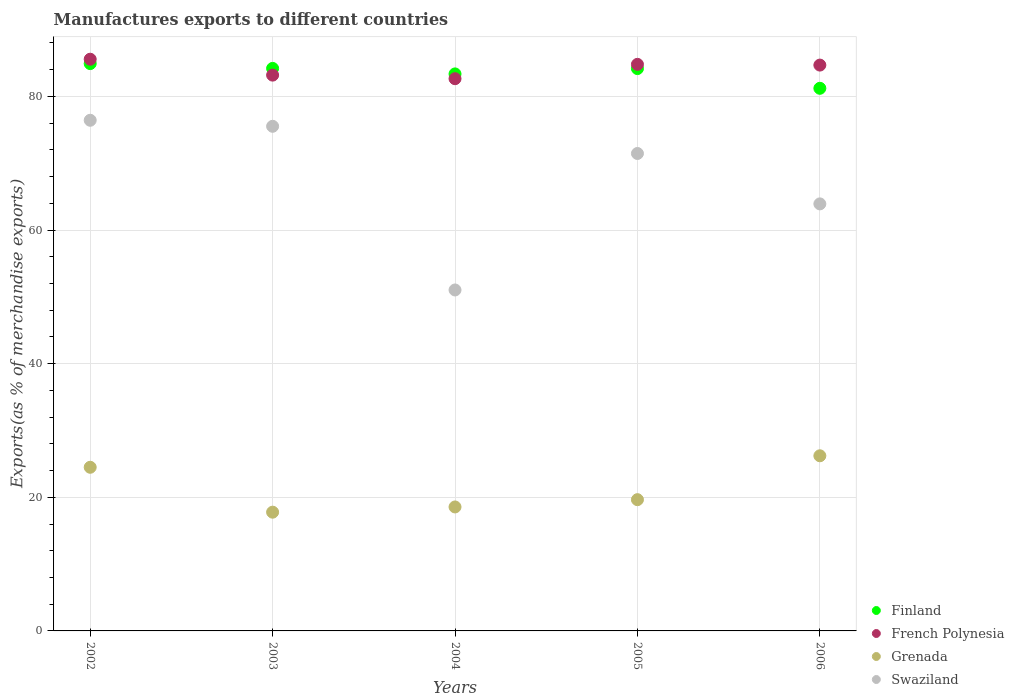Is the number of dotlines equal to the number of legend labels?
Your answer should be compact. Yes. What is the percentage of exports to different countries in Grenada in 2004?
Provide a succinct answer. 18.56. Across all years, what is the maximum percentage of exports to different countries in French Polynesia?
Your answer should be compact. 85.57. Across all years, what is the minimum percentage of exports to different countries in Grenada?
Your answer should be very brief. 17.77. In which year was the percentage of exports to different countries in Finland maximum?
Your response must be concise. 2002. What is the total percentage of exports to different countries in Swaziland in the graph?
Your response must be concise. 338.38. What is the difference between the percentage of exports to different countries in Swaziland in 2002 and that in 2005?
Keep it short and to the point. 4.97. What is the difference between the percentage of exports to different countries in French Polynesia in 2002 and the percentage of exports to different countries in Swaziland in 2005?
Your answer should be compact. 14.11. What is the average percentage of exports to different countries in Grenada per year?
Offer a terse response. 21.34. In the year 2006, what is the difference between the percentage of exports to different countries in Finland and percentage of exports to different countries in French Polynesia?
Ensure brevity in your answer.  -3.47. What is the ratio of the percentage of exports to different countries in French Polynesia in 2002 to that in 2006?
Your answer should be compact. 1.01. What is the difference between the highest and the second highest percentage of exports to different countries in Finland?
Ensure brevity in your answer.  0.72. What is the difference between the highest and the lowest percentage of exports to different countries in French Polynesia?
Make the answer very short. 2.92. In how many years, is the percentage of exports to different countries in Swaziland greater than the average percentage of exports to different countries in Swaziland taken over all years?
Your answer should be very brief. 3. Is it the case that in every year, the sum of the percentage of exports to different countries in French Polynesia and percentage of exports to different countries in Swaziland  is greater than the sum of percentage of exports to different countries in Grenada and percentage of exports to different countries in Finland?
Provide a succinct answer. No. Is it the case that in every year, the sum of the percentage of exports to different countries in Grenada and percentage of exports to different countries in Swaziland  is greater than the percentage of exports to different countries in Finland?
Your answer should be very brief. No. Does the percentage of exports to different countries in Swaziland monotonically increase over the years?
Ensure brevity in your answer.  No. How many years are there in the graph?
Provide a succinct answer. 5. What is the difference between two consecutive major ticks on the Y-axis?
Your answer should be very brief. 20. How many legend labels are there?
Offer a very short reply. 4. How are the legend labels stacked?
Provide a succinct answer. Vertical. What is the title of the graph?
Your answer should be compact. Manufactures exports to different countries. What is the label or title of the Y-axis?
Offer a very short reply. Exports(as % of merchandise exports). What is the Exports(as % of merchandise exports) in Finland in 2002?
Provide a succinct answer. 84.92. What is the Exports(as % of merchandise exports) of French Polynesia in 2002?
Provide a short and direct response. 85.57. What is the Exports(as % of merchandise exports) in Grenada in 2002?
Offer a very short reply. 24.49. What is the Exports(as % of merchandise exports) in Swaziland in 2002?
Your response must be concise. 76.43. What is the Exports(as % of merchandise exports) of Finland in 2003?
Offer a very short reply. 84.2. What is the Exports(as % of merchandise exports) in French Polynesia in 2003?
Your answer should be compact. 83.19. What is the Exports(as % of merchandise exports) of Grenada in 2003?
Your answer should be very brief. 17.77. What is the Exports(as % of merchandise exports) of Swaziland in 2003?
Offer a terse response. 75.53. What is the Exports(as % of merchandise exports) of Finland in 2004?
Provide a short and direct response. 83.37. What is the Exports(as % of merchandise exports) of French Polynesia in 2004?
Offer a very short reply. 82.66. What is the Exports(as % of merchandise exports) of Grenada in 2004?
Make the answer very short. 18.56. What is the Exports(as % of merchandise exports) in Swaziland in 2004?
Provide a short and direct response. 51.03. What is the Exports(as % of merchandise exports) of Finland in 2005?
Provide a succinct answer. 84.17. What is the Exports(as % of merchandise exports) in French Polynesia in 2005?
Keep it short and to the point. 84.8. What is the Exports(as % of merchandise exports) in Grenada in 2005?
Ensure brevity in your answer.  19.65. What is the Exports(as % of merchandise exports) in Swaziland in 2005?
Make the answer very short. 71.46. What is the Exports(as % of merchandise exports) of Finland in 2006?
Ensure brevity in your answer.  81.22. What is the Exports(as % of merchandise exports) in French Polynesia in 2006?
Your answer should be very brief. 84.69. What is the Exports(as % of merchandise exports) in Grenada in 2006?
Keep it short and to the point. 26.21. What is the Exports(as % of merchandise exports) in Swaziland in 2006?
Provide a succinct answer. 63.92. Across all years, what is the maximum Exports(as % of merchandise exports) of Finland?
Offer a terse response. 84.92. Across all years, what is the maximum Exports(as % of merchandise exports) in French Polynesia?
Offer a terse response. 85.57. Across all years, what is the maximum Exports(as % of merchandise exports) in Grenada?
Ensure brevity in your answer.  26.21. Across all years, what is the maximum Exports(as % of merchandise exports) of Swaziland?
Offer a very short reply. 76.43. Across all years, what is the minimum Exports(as % of merchandise exports) of Finland?
Keep it short and to the point. 81.22. Across all years, what is the minimum Exports(as % of merchandise exports) of French Polynesia?
Your response must be concise. 82.66. Across all years, what is the minimum Exports(as % of merchandise exports) in Grenada?
Provide a succinct answer. 17.77. Across all years, what is the minimum Exports(as % of merchandise exports) in Swaziland?
Your answer should be very brief. 51.03. What is the total Exports(as % of merchandise exports) in Finland in the graph?
Your answer should be very brief. 417.87. What is the total Exports(as % of merchandise exports) in French Polynesia in the graph?
Ensure brevity in your answer.  420.91. What is the total Exports(as % of merchandise exports) in Grenada in the graph?
Make the answer very short. 106.68. What is the total Exports(as % of merchandise exports) in Swaziland in the graph?
Keep it short and to the point. 338.38. What is the difference between the Exports(as % of merchandise exports) in Finland in 2002 and that in 2003?
Offer a terse response. 0.72. What is the difference between the Exports(as % of merchandise exports) in French Polynesia in 2002 and that in 2003?
Make the answer very short. 2.38. What is the difference between the Exports(as % of merchandise exports) in Grenada in 2002 and that in 2003?
Ensure brevity in your answer.  6.72. What is the difference between the Exports(as % of merchandise exports) of Swaziland in 2002 and that in 2003?
Your response must be concise. 0.9. What is the difference between the Exports(as % of merchandise exports) of Finland in 2002 and that in 2004?
Offer a terse response. 1.54. What is the difference between the Exports(as % of merchandise exports) in French Polynesia in 2002 and that in 2004?
Ensure brevity in your answer.  2.92. What is the difference between the Exports(as % of merchandise exports) in Grenada in 2002 and that in 2004?
Offer a very short reply. 5.94. What is the difference between the Exports(as % of merchandise exports) of Swaziland in 2002 and that in 2004?
Provide a short and direct response. 25.4. What is the difference between the Exports(as % of merchandise exports) in Finland in 2002 and that in 2005?
Your response must be concise. 0.75. What is the difference between the Exports(as % of merchandise exports) of French Polynesia in 2002 and that in 2005?
Provide a succinct answer. 0.77. What is the difference between the Exports(as % of merchandise exports) of Grenada in 2002 and that in 2005?
Offer a terse response. 4.85. What is the difference between the Exports(as % of merchandise exports) in Swaziland in 2002 and that in 2005?
Give a very brief answer. 4.97. What is the difference between the Exports(as % of merchandise exports) of Finland in 2002 and that in 2006?
Provide a short and direct response. 3.7. What is the difference between the Exports(as % of merchandise exports) in French Polynesia in 2002 and that in 2006?
Provide a succinct answer. 0.88. What is the difference between the Exports(as % of merchandise exports) in Grenada in 2002 and that in 2006?
Provide a short and direct response. -1.72. What is the difference between the Exports(as % of merchandise exports) of Swaziland in 2002 and that in 2006?
Provide a succinct answer. 12.52. What is the difference between the Exports(as % of merchandise exports) in Finland in 2003 and that in 2004?
Provide a short and direct response. 0.82. What is the difference between the Exports(as % of merchandise exports) in French Polynesia in 2003 and that in 2004?
Provide a succinct answer. 0.54. What is the difference between the Exports(as % of merchandise exports) of Grenada in 2003 and that in 2004?
Provide a succinct answer. -0.78. What is the difference between the Exports(as % of merchandise exports) in Swaziland in 2003 and that in 2004?
Give a very brief answer. 24.5. What is the difference between the Exports(as % of merchandise exports) of Finland in 2003 and that in 2005?
Offer a terse response. 0.03. What is the difference between the Exports(as % of merchandise exports) in French Polynesia in 2003 and that in 2005?
Your answer should be compact. -1.61. What is the difference between the Exports(as % of merchandise exports) of Grenada in 2003 and that in 2005?
Your answer should be very brief. -1.87. What is the difference between the Exports(as % of merchandise exports) in Swaziland in 2003 and that in 2005?
Offer a very short reply. 4.07. What is the difference between the Exports(as % of merchandise exports) of Finland in 2003 and that in 2006?
Offer a very short reply. 2.98. What is the difference between the Exports(as % of merchandise exports) of French Polynesia in 2003 and that in 2006?
Provide a succinct answer. -1.5. What is the difference between the Exports(as % of merchandise exports) of Grenada in 2003 and that in 2006?
Your answer should be compact. -8.44. What is the difference between the Exports(as % of merchandise exports) of Swaziland in 2003 and that in 2006?
Provide a succinct answer. 11.61. What is the difference between the Exports(as % of merchandise exports) of Finland in 2004 and that in 2005?
Your answer should be compact. -0.8. What is the difference between the Exports(as % of merchandise exports) of French Polynesia in 2004 and that in 2005?
Offer a terse response. -2.15. What is the difference between the Exports(as % of merchandise exports) in Grenada in 2004 and that in 2005?
Provide a short and direct response. -1.09. What is the difference between the Exports(as % of merchandise exports) in Swaziland in 2004 and that in 2005?
Make the answer very short. -20.43. What is the difference between the Exports(as % of merchandise exports) in Finland in 2004 and that in 2006?
Make the answer very short. 2.15. What is the difference between the Exports(as % of merchandise exports) in French Polynesia in 2004 and that in 2006?
Ensure brevity in your answer.  -2.04. What is the difference between the Exports(as % of merchandise exports) in Grenada in 2004 and that in 2006?
Provide a succinct answer. -7.66. What is the difference between the Exports(as % of merchandise exports) in Swaziland in 2004 and that in 2006?
Offer a very short reply. -12.89. What is the difference between the Exports(as % of merchandise exports) in Finland in 2005 and that in 2006?
Offer a very short reply. 2.95. What is the difference between the Exports(as % of merchandise exports) of French Polynesia in 2005 and that in 2006?
Your answer should be very brief. 0.11. What is the difference between the Exports(as % of merchandise exports) in Grenada in 2005 and that in 2006?
Your answer should be very brief. -6.57. What is the difference between the Exports(as % of merchandise exports) of Swaziland in 2005 and that in 2006?
Keep it short and to the point. 7.54. What is the difference between the Exports(as % of merchandise exports) of Finland in 2002 and the Exports(as % of merchandise exports) of French Polynesia in 2003?
Give a very brief answer. 1.73. What is the difference between the Exports(as % of merchandise exports) in Finland in 2002 and the Exports(as % of merchandise exports) in Grenada in 2003?
Make the answer very short. 67.14. What is the difference between the Exports(as % of merchandise exports) in Finland in 2002 and the Exports(as % of merchandise exports) in Swaziland in 2003?
Keep it short and to the point. 9.38. What is the difference between the Exports(as % of merchandise exports) of French Polynesia in 2002 and the Exports(as % of merchandise exports) of Grenada in 2003?
Give a very brief answer. 67.8. What is the difference between the Exports(as % of merchandise exports) in French Polynesia in 2002 and the Exports(as % of merchandise exports) in Swaziland in 2003?
Give a very brief answer. 10.04. What is the difference between the Exports(as % of merchandise exports) in Grenada in 2002 and the Exports(as % of merchandise exports) in Swaziland in 2003?
Your answer should be compact. -51.04. What is the difference between the Exports(as % of merchandise exports) in Finland in 2002 and the Exports(as % of merchandise exports) in French Polynesia in 2004?
Ensure brevity in your answer.  2.26. What is the difference between the Exports(as % of merchandise exports) of Finland in 2002 and the Exports(as % of merchandise exports) of Grenada in 2004?
Make the answer very short. 66.36. What is the difference between the Exports(as % of merchandise exports) of Finland in 2002 and the Exports(as % of merchandise exports) of Swaziland in 2004?
Make the answer very short. 33.88. What is the difference between the Exports(as % of merchandise exports) in French Polynesia in 2002 and the Exports(as % of merchandise exports) in Grenada in 2004?
Your answer should be compact. 67.02. What is the difference between the Exports(as % of merchandise exports) of French Polynesia in 2002 and the Exports(as % of merchandise exports) of Swaziland in 2004?
Offer a terse response. 34.54. What is the difference between the Exports(as % of merchandise exports) of Grenada in 2002 and the Exports(as % of merchandise exports) of Swaziland in 2004?
Your answer should be very brief. -26.54. What is the difference between the Exports(as % of merchandise exports) of Finland in 2002 and the Exports(as % of merchandise exports) of French Polynesia in 2005?
Your answer should be very brief. 0.11. What is the difference between the Exports(as % of merchandise exports) of Finland in 2002 and the Exports(as % of merchandise exports) of Grenada in 2005?
Provide a short and direct response. 65.27. What is the difference between the Exports(as % of merchandise exports) in Finland in 2002 and the Exports(as % of merchandise exports) in Swaziland in 2005?
Make the answer very short. 13.45. What is the difference between the Exports(as % of merchandise exports) of French Polynesia in 2002 and the Exports(as % of merchandise exports) of Grenada in 2005?
Offer a terse response. 65.92. What is the difference between the Exports(as % of merchandise exports) of French Polynesia in 2002 and the Exports(as % of merchandise exports) of Swaziland in 2005?
Keep it short and to the point. 14.11. What is the difference between the Exports(as % of merchandise exports) in Grenada in 2002 and the Exports(as % of merchandise exports) in Swaziland in 2005?
Ensure brevity in your answer.  -46.97. What is the difference between the Exports(as % of merchandise exports) in Finland in 2002 and the Exports(as % of merchandise exports) in French Polynesia in 2006?
Provide a short and direct response. 0.22. What is the difference between the Exports(as % of merchandise exports) in Finland in 2002 and the Exports(as % of merchandise exports) in Grenada in 2006?
Your answer should be very brief. 58.7. What is the difference between the Exports(as % of merchandise exports) of Finland in 2002 and the Exports(as % of merchandise exports) of Swaziland in 2006?
Your answer should be compact. 21. What is the difference between the Exports(as % of merchandise exports) in French Polynesia in 2002 and the Exports(as % of merchandise exports) in Grenada in 2006?
Make the answer very short. 59.36. What is the difference between the Exports(as % of merchandise exports) of French Polynesia in 2002 and the Exports(as % of merchandise exports) of Swaziland in 2006?
Offer a terse response. 21.65. What is the difference between the Exports(as % of merchandise exports) in Grenada in 2002 and the Exports(as % of merchandise exports) in Swaziland in 2006?
Your answer should be very brief. -39.42. What is the difference between the Exports(as % of merchandise exports) of Finland in 2003 and the Exports(as % of merchandise exports) of French Polynesia in 2004?
Give a very brief answer. 1.54. What is the difference between the Exports(as % of merchandise exports) of Finland in 2003 and the Exports(as % of merchandise exports) of Grenada in 2004?
Your answer should be very brief. 65.64. What is the difference between the Exports(as % of merchandise exports) in Finland in 2003 and the Exports(as % of merchandise exports) in Swaziland in 2004?
Ensure brevity in your answer.  33.16. What is the difference between the Exports(as % of merchandise exports) in French Polynesia in 2003 and the Exports(as % of merchandise exports) in Grenada in 2004?
Your answer should be very brief. 64.64. What is the difference between the Exports(as % of merchandise exports) in French Polynesia in 2003 and the Exports(as % of merchandise exports) in Swaziland in 2004?
Give a very brief answer. 32.16. What is the difference between the Exports(as % of merchandise exports) of Grenada in 2003 and the Exports(as % of merchandise exports) of Swaziland in 2004?
Your response must be concise. -33.26. What is the difference between the Exports(as % of merchandise exports) of Finland in 2003 and the Exports(as % of merchandise exports) of French Polynesia in 2005?
Give a very brief answer. -0.61. What is the difference between the Exports(as % of merchandise exports) of Finland in 2003 and the Exports(as % of merchandise exports) of Grenada in 2005?
Your response must be concise. 64.55. What is the difference between the Exports(as % of merchandise exports) of Finland in 2003 and the Exports(as % of merchandise exports) of Swaziland in 2005?
Keep it short and to the point. 12.73. What is the difference between the Exports(as % of merchandise exports) in French Polynesia in 2003 and the Exports(as % of merchandise exports) in Grenada in 2005?
Offer a very short reply. 63.54. What is the difference between the Exports(as % of merchandise exports) in French Polynesia in 2003 and the Exports(as % of merchandise exports) in Swaziland in 2005?
Keep it short and to the point. 11.73. What is the difference between the Exports(as % of merchandise exports) of Grenada in 2003 and the Exports(as % of merchandise exports) of Swaziland in 2005?
Provide a short and direct response. -53.69. What is the difference between the Exports(as % of merchandise exports) in Finland in 2003 and the Exports(as % of merchandise exports) in French Polynesia in 2006?
Keep it short and to the point. -0.5. What is the difference between the Exports(as % of merchandise exports) in Finland in 2003 and the Exports(as % of merchandise exports) in Grenada in 2006?
Your answer should be very brief. 57.98. What is the difference between the Exports(as % of merchandise exports) in Finland in 2003 and the Exports(as % of merchandise exports) in Swaziland in 2006?
Offer a very short reply. 20.28. What is the difference between the Exports(as % of merchandise exports) of French Polynesia in 2003 and the Exports(as % of merchandise exports) of Grenada in 2006?
Give a very brief answer. 56.98. What is the difference between the Exports(as % of merchandise exports) of French Polynesia in 2003 and the Exports(as % of merchandise exports) of Swaziland in 2006?
Your answer should be very brief. 19.27. What is the difference between the Exports(as % of merchandise exports) of Grenada in 2003 and the Exports(as % of merchandise exports) of Swaziland in 2006?
Offer a terse response. -46.15. What is the difference between the Exports(as % of merchandise exports) in Finland in 2004 and the Exports(as % of merchandise exports) in French Polynesia in 2005?
Your answer should be very brief. -1.43. What is the difference between the Exports(as % of merchandise exports) in Finland in 2004 and the Exports(as % of merchandise exports) in Grenada in 2005?
Provide a short and direct response. 63.73. What is the difference between the Exports(as % of merchandise exports) of Finland in 2004 and the Exports(as % of merchandise exports) of Swaziland in 2005?
Ensure brevity in your answer.  11.91. What is the difference between the Exports(as % of merchandise exports) of French Polynesia in 2004 and the Exports(as % of merchandise exports) of Grenada in 2005?
Provide a short and direct response. 63.01. What is the difference between the Exports(as % of merchandise exports) in French Polynesia in 2004 and the Exports(as % of merchandise exports) in Swaziland in 2005?
Make the answer very short. 11.19. What is the difference between the Exports(as % of merchandise exports) of Grenada in 2004 and the Exports(as % of merchandise exports) of Swaziland in 2005?
Offer a very short reply. -52.91. What is the difference between the Exports(as % of merchandise exports) of Finland in 2004 and the Exports(as % of merchandise exports) of French Polynesia in 2006?
Make the answer very short. -1.32. What is the difference between the Exports(as % of merchandise exports) of Finland in 2004 and the Exports(as % of merchandise exports) of Grenada in 2006?
Provide a short and direct response. 57.16. What is the difference between the Exports(as % of merchandise exports) in Finland in 2004 and the Exports(as % of merchandise exports) in Swaziland in 2006?
Provide a succinct answer. 19.45. What is the difference between the Exports(as % of merchandise exports) in French Polynesia in 2004 and the Exports(as % of merchandise exports) in Grenada in 2006?
Your response must be concise. 56.44. What is the difference between the Exports(as % of merchandise exports) in French Polynesia in 2004 and the Exports(as % of merchandise exports) in Swaziland in 2006?
Your response must be concise. 18.74. What is the difference between the Exports(as % of merchandise exports) in Grenada in 2004 and the Exports(as % of merchandise exports) in Swaziland in 2006?
Provide a succinct answer. -45.36. What is the difference between the Exports(as % of merchandise exports) of Finland in 2005 and the Exports(as % of merchandise exports) of French Polynesia in 2006?
Your answer should be very brief. -0.52. What is the difference between the Exports(as % of merchandise exports) of Finland in 2005 and the Exports(as % of merchandise exports) of Grenada in 2006?
Your answer should be compact. 57.96. What is the difference between the Exports(as % of merchandise exports) of Finland in 2005 and the Exports(as % of merchandise exports) of Swaziland in 2006?
Make the answer very short. 20.25. What is the difference between the Exports(as % of merchandise exports) in French Polynesia in 2005 and the Exports(as % of merchandise exports) in Grenada in 2006?
Your answer should be very brief. 58.59. What is the difference between the Exports(as % of merchandise exports) in French Polynesia in 2005 and the Exports(as % of merchandise exports) in Swaziland in 2006?
Your answer should be very brief. 20.88. What is the difference between the Exports(as % of merchandise exports) of Grenada in 2005 and the Exports(as % of merchandise exports) of Swaziland in 2006?
Provide a succinct answer. -44.27. What is the average Exports(as % of merchandise exports) in Finland per year?
Your response must be concise. 83.57. What is the average Exports(as % of merchandise exports) in French Polynesia per year?
Your answer should be compact. 84.18. What is the average Exports(as % of merchandise exports) of Grenada per year?
Keep it short and to the point. 21.34. What is the average Exports(as % of merchandise exports) of Swaziland per year?
Your answer should be very brief. 67.68. In the year 2002, what is the difference between the Exports(as % of merchandise exports) in Finland and Exports(as % of merchandise exports) in French Polynesia?
Your answer should be compact. -0.66. In the year 2002, what is the difference between the Exports(as % of merchandise exports) of Finland and Exports(as % of merchandise exports) of Grenada?
Make the answer very short. 60.42. In the year 2002, what is the difference between the Exports(as % of merchandise exports) of Finland and Exports(as % of merchandise exports) of Swaziland?
Your answer should be very brief. 8.48. In the year 2002, what is the difference between the Exports(as % of merchandise exports) in French Polynesia and Exports(as % of merchandise exports) in Grenada?
Your answer should be compact. 61.08. In the year 2002, what is the difference between the Exports(as % of merchandise exports) in French Polynesia and Exports(as % of merchandise exports) in Swaziland?
Provide a succinct answer. 9.14. In the year 2002, what is the difference between the Exports(as % of merchandise exports) in Grenada and Exports(as % of merchandise exports) in Swaziland?
Your answer should be compact. -51.94. In the year 2003, what is the difference between the Exports(as % of merchandise exports) of Finland and Exports(as % of merchandise exports) of Grenada?
Provide a short and direct response. 66.42. In the year 2003, what is the difference between the Exports(as % of merchandise exports) in Finland and Exports(as % of merchandise exports) in Swaziland?
Your response must be concise. 8.66. In the year 2003, what is the difference between the Exports(as % of merchandise exports) in French Polynesia and Exports(as % of merchandise exports) in Grenada?
Make the answer very short. 65.42. In the year 2003, what is the difference between the Exports(as % of merchandise exports) of French Polynesia and Exports(as % of merchandise exports) of Swaziland?
Your answer should be compact. 7.66. In the year 2003, what is the difference between the Exports(as % of merchandise exports) in Grenada and Exports(as % of merchandise exports) in Swaziland?
Your answer should be very brief. -57.76. In the year 2004, what is the difference between the Exports(as % of merchandise exports) of Finland and Exports(as % of merchandise exports) of French Polynesia?
Your answer should be compact. 0.72. In the year 2004, what is the difference between the Exports(as % of merchandise exports) in Finland and Exports(as % of merchandise exports) in Grenada?
Ensure brevity in your answer.  64.82. In the year 2004, what is the difference between the Exports(as % of merchandise exports) of Finland and Exports(as % of merchandise exports) of Swaziland?
Give a very brief answer. 32.34. In the year 2004, what is the difference between the Exports(as % of merchandise exports) of French Polynesia and Exports(as % of merchandise exports) of Grenada?
Provide a short and direct response. 64.1. In the year 2004, what is the difference between the Exports(as % of merchandise exports) of French Polynesia and Exports(as % of merchandise exports) of Swaziland?
Your answer should be compact. 31.62. In the year 2004, what is the difference between the Exports(as % of merchandise exports) in Grenada and Exports(as % of merchandise exports) in Swaziland?
Provide a succinct answer. -32.48. In the year 2005, what is the difference between the Exports(as % of merchandise exports) of Finland and Exports(as % of merchandise exports) of French Polynesia?
Provide a short and direct response. -0.63. In the year 2005, what is the difference between the Exports(as % of merchandise exports) of Finland and Exports(as % of merchandise exports) of Grenada?
Give a very brief answer. 64.52. In the year 2005, what is the difference between the Exports(as % of merchandise exports) of Finland and Exports(as % of merchandise exports) of Swaziland?
Keep it short and to the point. 12.71. In the year 2005, what is the difference between the Exports(as % of merchandise exports) in French Polynesia and Exports(as % of merchandise exports) in Grenada?
Your response must be concise. 65.16. In the year 2005, what is the difference between the Exports(as % of merchandise exports) in French Polynesia and Exports(as % of merchandise exports) in Swaziland?
Offer a very short reply. 13.34. In the year 2005, what is the difference between the Exports(as % of merchandise exports) of Grenada and Exports(as % of merchandise exports) of Swaziland?
Give a very brief answer. -51.82. In the year 2006, what is the difference between the Exports(as % of merchandise exports) of Finland and Exports(as % of merchandise exports) of French Polynesia?
Keep it short and to the point. -3.47. In the year 2006, what is the difference between the Exports(as % of merchandise exports) of Finland and Exports(as % of merchandise exports) of Grenada?
Your response must be concise. 55. In the year 2006, what is the difference between the Exports(as % of merchandise exports) in Finland and Exports(as % of merchandise exports) in Swaziland?
Ensure brevity in your answer.  17.3. In the year 2006, what is the difference between the Exports(as % of merchandise exports) of French Polynesia and Exports(as % of merchandise exports) of Grenada?
Give a very brief answer. 58.48. In the year 2006, what is the difference between the Exports(as % of merchandise exports) of French Polynesia and Exports(as % of merchandise exports) of Swaziland?
Provide a short and direct response. 20.77. In the year 2006, what is the difference between the Exports(as % of merchandise exports) in Grenada and Exports(as % of merchandise exports) in Swaziland?
Your response must be concise. -37.7. What is the ratio of the Exports(as % of merchandise exports) in Finland in 2002 to that in 2003?
Give a very brief answer. 1.01. What is the ratio of the Exports(as % of merchandise exports) in French Polynesia in 2002 to that in 2003?
Ensure brevity in your answer.  1.03. What is the ratio of the Exports(as % of merchandise exports) in Grenada in 2002 to that in 2003?
Offer a terse response. 1.38. What is the ratio of the Exports(as % of merchandise exports) of Swaziland in 2002 to that in 2003?
Provide a succinct answer. 1.01. What is the ratio of the Exports(as % of merchandise exports) of Finland in 2002 to that in 2004?
Your answer should be very brief. 1.02. What is the ratio of the Exports(as % of merchandise exports) of French Polynesia in 2002 to that in 2004?
Give a very brief answer. 1.04. What is the ratio of the Exports(as % of merchandise exports) of Grenada in 2002 to that in 2004?
Ensure brevity in your answer.  1.32. What is the ratio of the Exports(as % of merchandise exports) in Swaziland in 2002 to that in 2004?
Keep it short and to the point. 1.5. What is the ratio of the Exports(as % of merchandise exports) in Finland in 2002 to that in 2005?
Ensure brevity in your answer.  1.01. What is the ratio of the Exports(as % of merchandise exports) of French Polynesia in 2002 to that in 2005?
Offer a very short reply. 1.01. What is the ratio of the Exports(as % of merchandise exports) in Grenada in 2002 to that in 2005?
Your response must be concise. 1.25. What is the ratio of the Exports(as % of merchandise exports) of Swaziland in 2002 to that in 2005?
Your response must be concise. 1.07. What is the ratio of the Exports(as % of merchandise exports) in Finland in 2002 to that in 2006?
Provide a short and direct response. 1.05. What is the ratio of the Exports(as % of merchandise exports) of French Polynesia in 2002 to that in 2006?
Your response must be concise. 1.01. What is the ratio of the Exports(as % of merchandise exports) in Grenada in 2002 to that in 2006?
Make the answer very short. 0.93. What is the ratio of the Exports(as % of merchandise exports) of Swaziland in 2002 to that in 2006?
Give a very brief answer. 1.2. What is the ratio of the Exports(as % of merchandise exports) in Finland in 2003 to that in 2004?
Provide a succinct answer. 1.01. What is the ratio of the Exports(as % of merchandise exports) of Grenada in 2003 to that in 2004?
Make the answer very short. 0.96. What is the ratio of the Exports(as % of merchandise exports) in Swaziland in 2003 to that in 2004?
Keep it short and to the point. 1.48. What is the ratio of the Exports(as % of merchandise exports) of Finland in 2003 to that in 2005?
Your answer should be compact. 1. What is the ratio of the Exports(as % of merchandise exports) in French Polynesia in 2003 to that in 2005?
Your answer should be very brief. 0.98. What is the ratio of the Exports(as % of merchandise exports) in Grenada in 2003 to that in 2005?
Your answer should be very brief. 0.9. What is the ratio of the Exports(as % of merchandise exports) in Swaziland in 2003 to that in 2005?
Your response must be concise. 1.06. What is the ratio of the Exports(as % of merchandise exports) in Finland in 2003 to that in 2006?
Offer a terse response. 1.04. What is the ratio of the Exports(as % of merchandise exports) of French Polynesia in 2003 to that in 2006?
Provide a short and direct response. 0.98. What is the ratio of the Exports(as % of merchandise exports) of Grenada in 2003 to that in 2006?
Make the answer very short. 0.68. What is the ratio of the Exports(as % of merchandise exports) in Swaziland in 2003 to that in 2006?
Make the answer very short. 1.18. What is the ratio of the Exports(as % of merchandise exports) in French Polynesia in 2004 to that in 2005?
Your response must be concise. 0.97. What is the ratio of the Exports(as % of merchandise exports) of Grenada in 2004 to that in 2005?
Keep it short and to the point. 0.94. What is the ratio of the Exports(as % of merchandise exports) in Swaziland in 2004 to that in 2005?
Give a very brief answer. 0.71. What is the ratio of the Exports(as % of merchandise exports) in Finland in 2004 to that in 2006?
Your answer should be compact. 1.03. What is the ratio of the Exports(as % of merchandise exports) of French Polynesia in 2004 to that in 2006?
Your answer should be compact. 0.98. What is the ratio of the Exports(as % of merchandise exports) of Grenada in 2004 to that in 2006?
Offer a terse response. 0.71. What is the ratio of the Exports(as % of merchandise exports) in Swaziland in 2004 to that in 2006?
Your response must be concise. 0.8. What is the ratio of the Exports(as % of merchandise exports) of Finland in 2005 to that in 2006?
Ensure brevity in your answer.  1.04. What is the ratio of the Exports(as % of merchandise exports) in French Polynesia in 2005 to that in 2006?
Your answer should be very brief. 1. What is the ratio of the Exports(as % of merchandise exports) of Grenada in 2005 to that in 2006?
Give a very brief answer. 0.75. What is the ratio of the Exports(as % of merchandise exports) in Swaziland in 2005 to that in 2006?
Make the answer very short. 1.12. What is the difference between the highest and the second highest Exports(as % of merchandise exports) in Finland?
Make the answer very short. 0.72. What is the difference between the highest and the second highest Exports(as % of merchandise exports) in French Polynesia?
Offer a very short reply. 0.77. What is the difference between the highest and the second highest Exports(as % of merchandise exports) of Grenada?
Ensure brevity in your answer.  1.72. What is the difference between the highest and the second highest Exports(as % of merchandise exports) in Swaziland?
Your answer should be very brief. 0.9. What is the difference between the highest and the lowest Exports(as % of merchandise exports) of Finland?
Provide a succinct answer. 3.7. What is the difference between the highest and the lowest Exports(as % of merchandise exports) in French Polynesia?
Ensure brevity in your answer.  2.92. What is the difference between the highest and the lowest Exports(as % of merchandise exports) in Grenada?
Your answer should be compact. 8.44. What is the difference between the highest and the lowest Exports(as % of merchandise exports) in Swaziland?
Give a very brief answer. 25.4. 